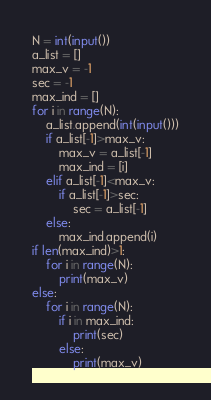Convert code to text. <code><loc_0><loc_0><loc_500><loc_500><_Python_>N = int(input())
a_list = []
max_v = -1
sec = -1
max_ind = []
for i in range(N):
    a_list.append(int(input()))
    if a_list[-1]>max_v:
        max_v = a_list[-1]
        max_ind = [i]
    elif a_list[-1]<max_v:
        if a_list[-1]>sec:
            sec = a_list[-1]
    else:
        max_ind.append(i)
if len(max_ind)>1:
    for i in range(N):
        print(max_v)
else:
    for i in range(N):
        if i in max_ind:
            print(sec)
        else:
            print(max_v)</code> 